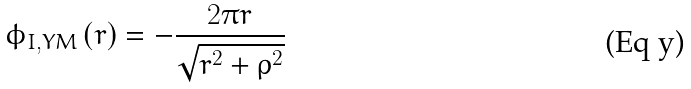<formula> <loc_0><loc_0><loc_500><loc_500>\phi _ { I , Y M } \left ( r \right ) = - \frac { 2 \pi r } { \sqrt { r ^ { 2 } + \rho ^ { 2 } } }</formula> 